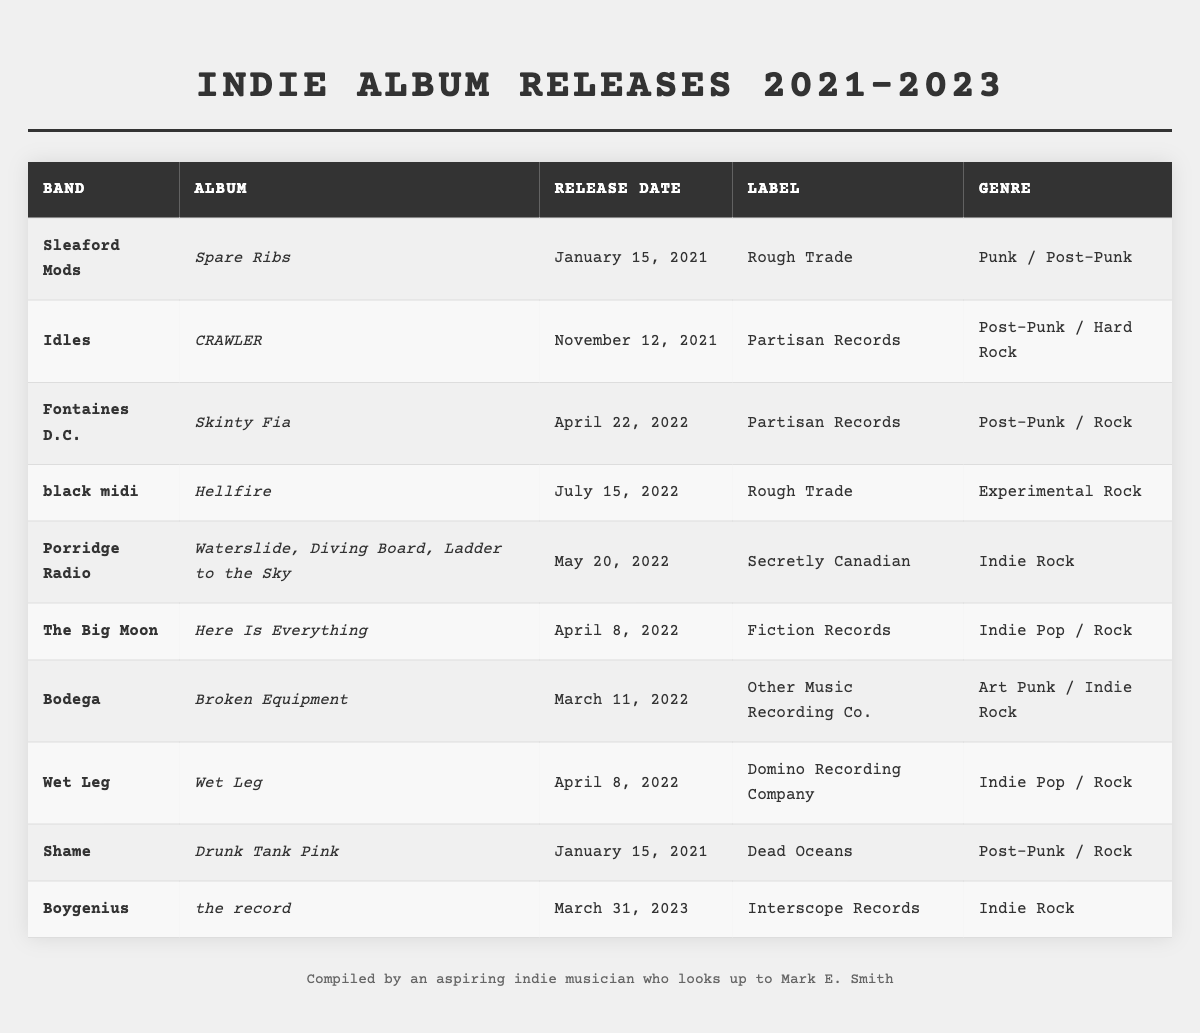What is the release date of "Waterslide, Diving Board, Ladder to the Sky" by Porridge Radio? The table lists the release date of "Waterslide, Diving Board, Ladder to the Sky" in the corresponding row, indicating it was released on May 20, 2022.
Answer: May 20, 2022 Which band released their album on July 15, 2022? By examining the table, we can see that black midi is listed as the band with an album released on July 15, 2022, titled "Hellfire."
Answer: black midi How many albums were released in April 2022? The table shows three entries with release dates in April 2022: "Here Is Everything" by The Big Moon, "Wet Leg" by Wet Leg, and "Skinty Fia" by Fontaines D.C. Therefore, the count is three.
Answer: 3 What genre does the album "Broken Equipment" belong to? The table indicates that the album "Broken Equipment" by Bodega is classified under the genre "Art Punk / Indie Rock."
Answer: Art Punk / Indie Rock Is "Hellfire" released by Rough Trade? By checking the table, we find that "Hellfire" by black midi is indeed listed under the Rough Trade label, confirming the fact.
Answer: Yes Which album has the earliest release date in the table? To determine the earliest release date, we can compare the dates listed in the table. "Spare Ribs" by Sleaford Mods is dated January 15, 2021, which is the earliest.
Answer: Spare Ribs How many indie rock albums were released in 2022? Looking at the table, there are three albums categorized as "Indie Rock": "Waterslide, Diving Board, Ladder to the Sky" by Porridge Radio, "Here Is Everything" by The Big Moon, and "Wet Leg" by Wet Leg. Thus, the total is three.
Answer: 3 Which album has the same release date as “Drunk Tank Pink”? By reviewing the table, "Drunk Tank Pink" by Shame shares its release date of January 15, 2021, with "Spare Ribs" by Sleaford Mods.
Answer: Spare Ribs What is the label for the album "CRAWLER"? The table lists that "CRAWLER" by Idles was released under the label "Partisan Records."
Answer: Partisan Records Which band has released an album under Domino Recording Company? By checking the entries, we see that Wet Leg is the band associated with the album titled "Wet Leg," which was released under Domino Recording Company.
Answer: Wet Leg 